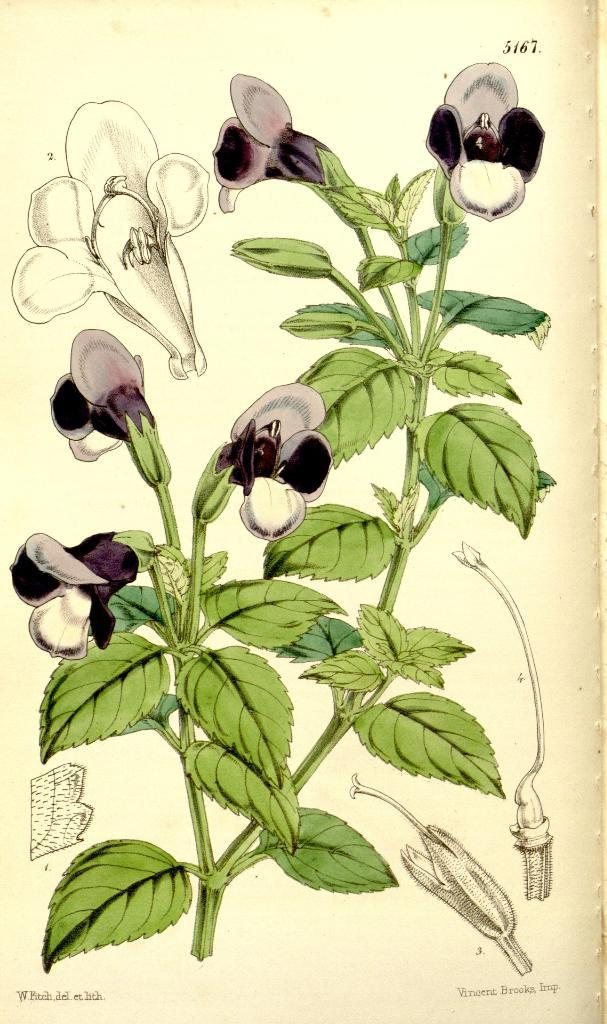What is the main subject of the image? The main subject of the image is a picture of a flower plant. Can you describe the flower plant in the image? Unfortunately, the facts provided do not give any details about the flower plant's appearance or characteristics. Is there anything else in the image besides the flower plant? The facts provided do not mention any other objects or subjects in the image. What type of journey does the vase take in the image? There is no vase present in the image, so it cannot take any journey. 